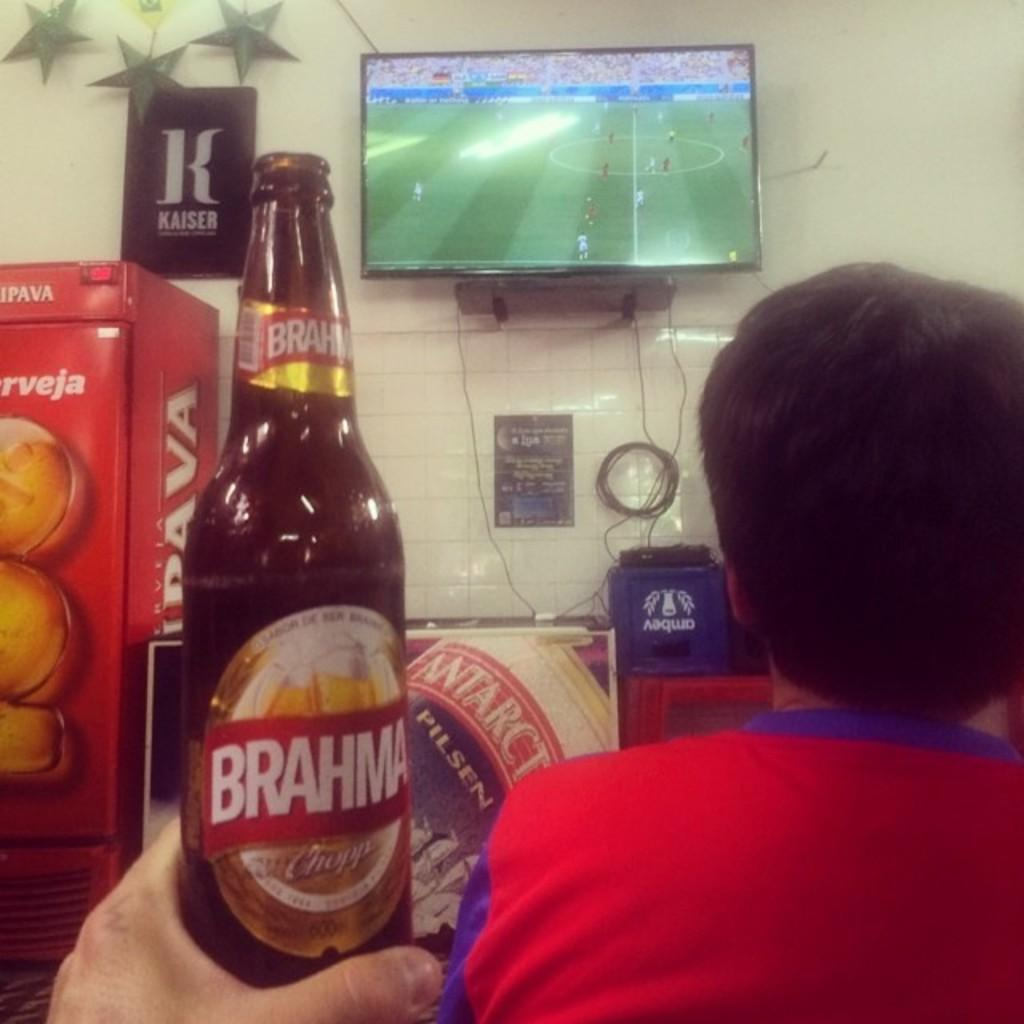What is the person in the image holding? The person is holding a bottle in the image. Can you describe the gender of the person in the image? There is a man in the image. What electronic device is present in the image? There is a television in the image. What type of wall decoration can be seen in the image? There is a poster in the image. How many chickens are visible in the image? There are no chickens present in the image. What is the person's level of wealth based on the image? The image does not provide any information about the person's wealth. 